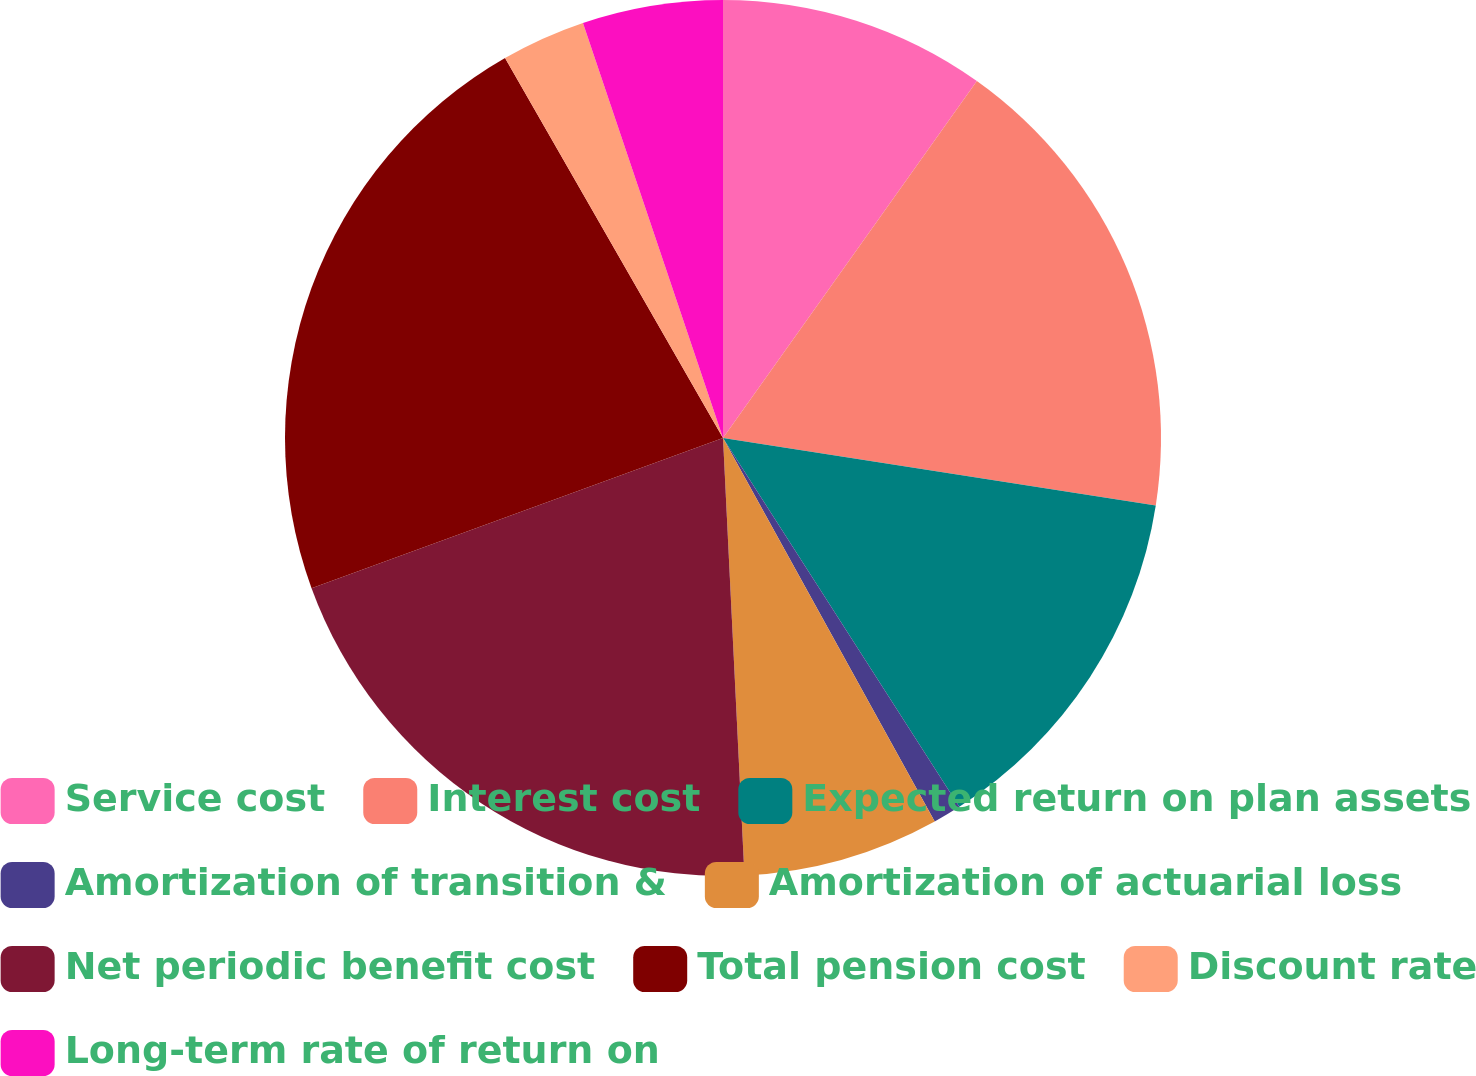Convert chart. <chart><loc_0><loc_0><loc_500><loc_500><pie_chart><fcel>Service cost<fcel>Interest cost<fcel>Expected return on plan assets<fcel>Amortization of transition &<fcel>Amortization of actuarial loss<fcel>Net periodic benefit cost<fcel>Total pension cost<fcel>Discount rate<fcel>Long-term rate of return on<nl><fcel>9.84%<fcel>17.62%<fcel>13.47%<fcel>1.04%<fcel>7.25%<fcel>20.21%<fcel>22.28%<fcel>3.11%<fcel>5.18%<nl></chart> 